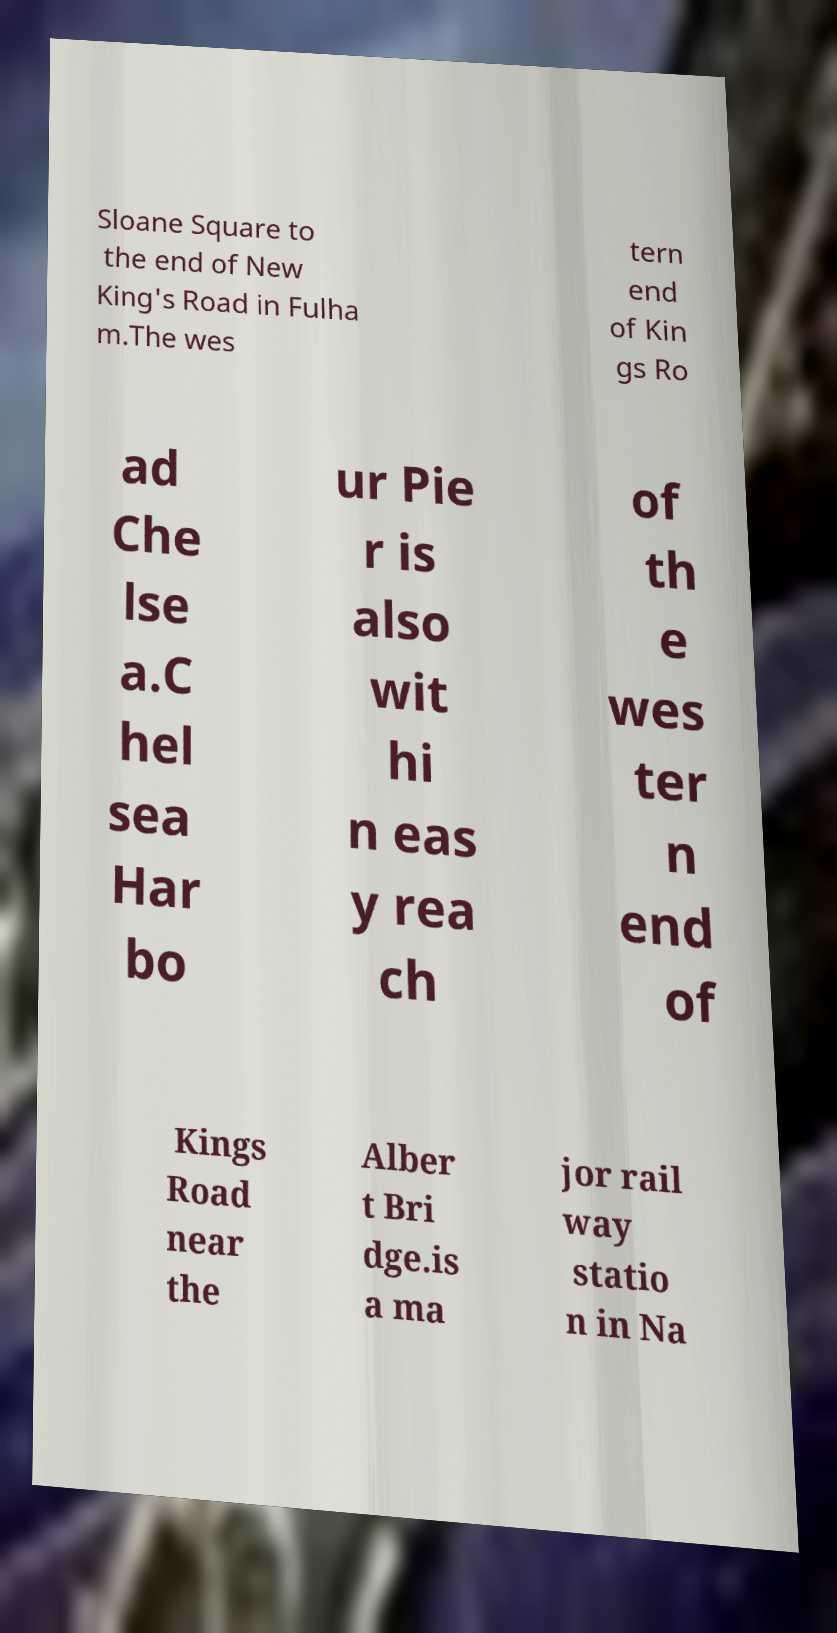Can you accurately transcribe the text from the provided image for me? Sloane Square to the end of New King's Road in Fulha m.The wes tern end of Kin gs Ro ad Che lse a.C hel sea Har bo ur Pie r is also wit hi n eas y rea ch of th e wes ter n end of Kings Road near the Alber t Bri dge.is a ma jor rail way statio n in Na 